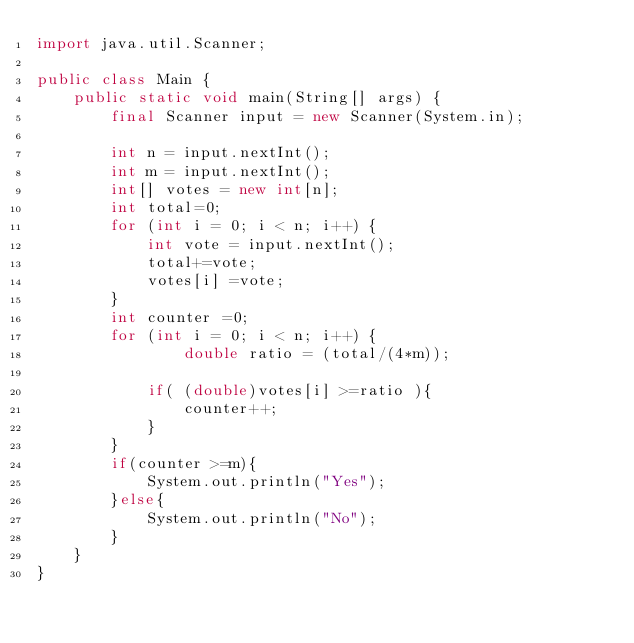<code> <loc_0><loc_0><loc_500><loc_500><_Java_>import java.util.Scanner;

public class Main {
    public static void main(String[] args) {
        final Scanner input = new Scanner(System.in);

        int n = input.nextInt();
        int m = input.nextInt();
        int[] votes = new int[n];
        int total=0;
        for (int i = 0; i < n; i++) {
            int vote = input.nextInt();
            total+=vote;
            votes[i] =vote;
        }
        int counter =0;
        for (int i = 0; i < n; i++) {
                double ratio = (total/(4*m));

            if( (double)votes[i] >=ratio ){
                counter++;
            }
        }
        if(counter >=m){
            System.out.println("Yes");
        }else{
            System.out.println("No");
        }
    }
}
</code> 